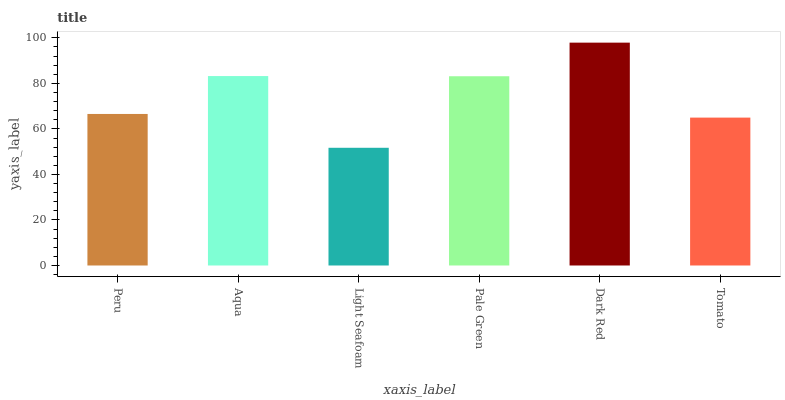Is Light Seafoam the minimum?
Answer yes or no. Yes. Is Dark Red the maximum?
Answer yes or no. Yes. Is Aqua the minimum?
Answer yes or no. No. Is Aqua the maximum?
Answer yes or no. No. Is Aqua greater than Peru?
Answer yes or no. Yes. Is Peru less than Aqua?
Answer yes or no. Yes. Is Peru greater than Aqua?
Answer yes or no. No. Is Aqua less than Peru?
Answer yes or no. No. Is Pale Green the high median?
Answer yes or no. Yes. Is Peru the low median?
Answer yes or no. Yes. Is Aqua the high median?
Answer yes or no. No. Is Dark Red the low median?
Answer yes or no. No. 